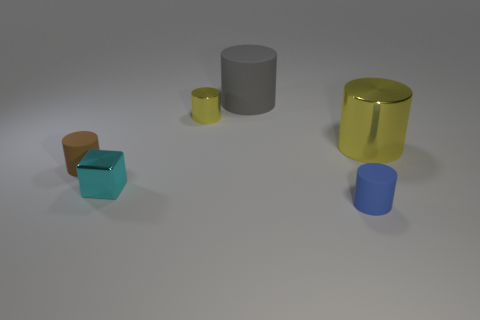Is the number of big gray matte cylinders greater than the number of small cyan cylinders? Yes, there is one large gray matte cylinder present, which exceeds the number of small cyan cylinders, as there are none in view. 